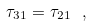Convert formula to latex. <formula><loc_0><loc_0><loc_500><loc_500>\tau _ { 3 1 } = \tau _ { 2 1 } \ ,</formula> 